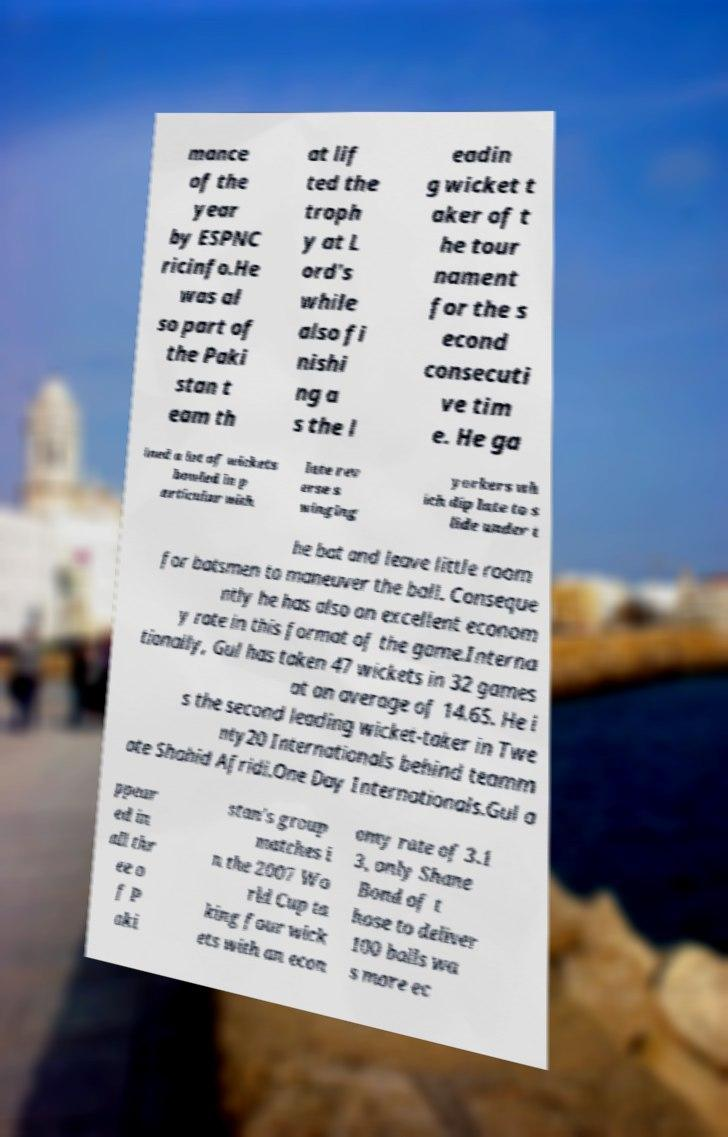Could you extract and type out the text from this image? mance of the year by ESPNC ricinfo.He was al so part of the Paki stan t eam th at lif ted the troph y at L ord's while also fi nishi ng a s the l eadin g wicket t aker of t he tour nament for the s econd consecuti ve tim e. He ga ined a lot of wickets bowled in p articular with late rev erse s winging yorkers wh ich dip late to s lide under t he bat and leave little room for batsmen to maneuver the ball. Conseque ntly he has also an excellent econom y rate in this format of the game.Interna tionally, Gul has taken 47 wickets in 32 games at an average of 14.65. He i s the second leading wicket-taker in Twe nty20 Internationals behind teamm ate Shahid Afridi.One Day Internationals.Gul a ppear ed in all thr ee o f P aki stan's group matches i n the 2007 Wo rld Cup ta king four wick ets with an econ omy rate of 3.1 3, only Shane Bond of t hose to deliver 100 balls wa s more ec 